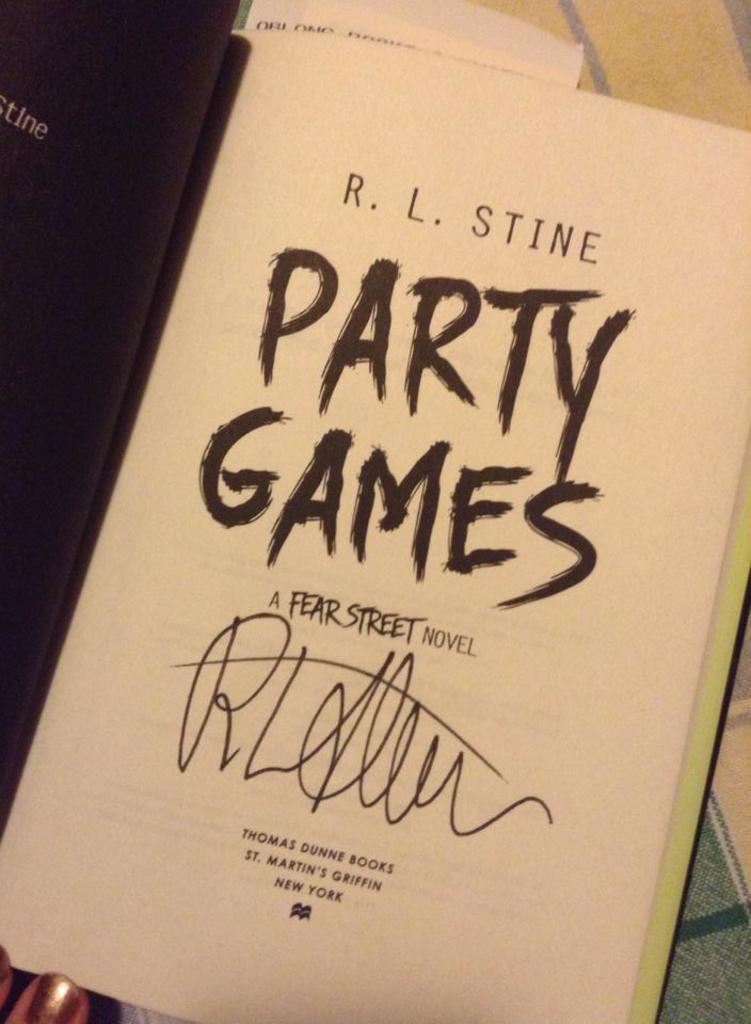<image>
Relay a brief, clear account of the picture shown. The title page of R. L. Stine's Party Games has been signed by the author. 